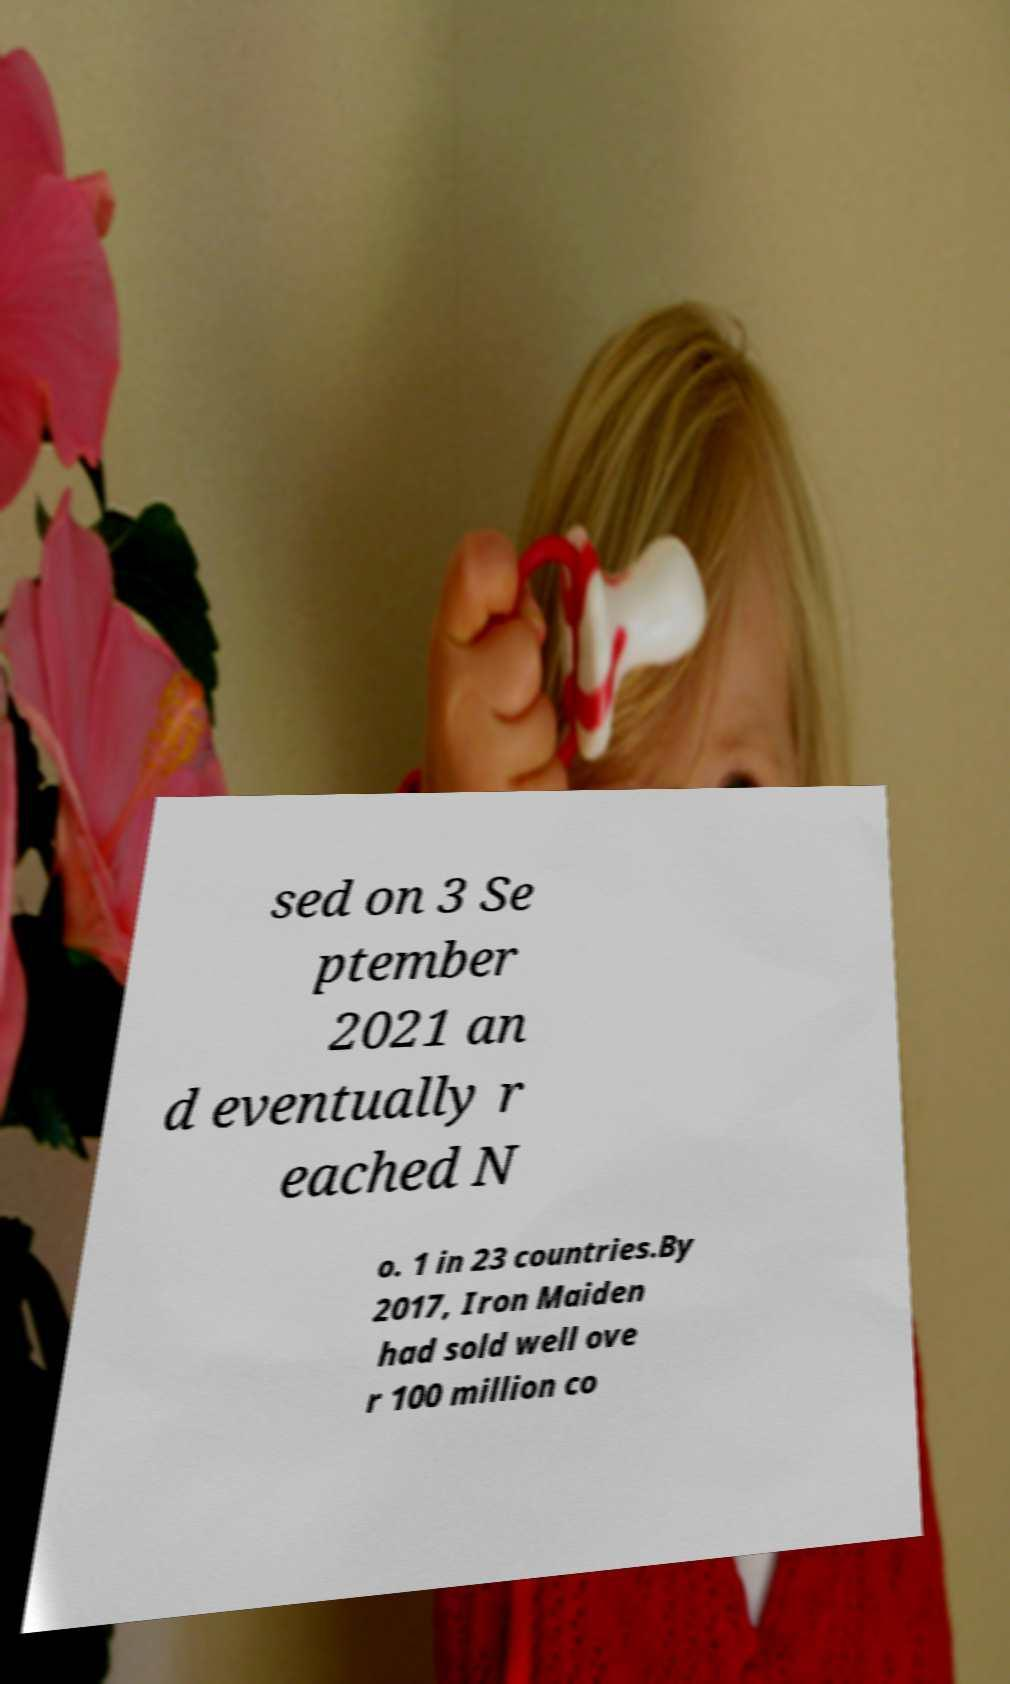There's text embedded in this image that I need extracted. Can you transcribe it verbatim? sed on 3 Se ptember 2021 an d eventually r eached N o. 1 in 23 countries.By 2017, Iron Maiden had sold well ove r 100 million co 